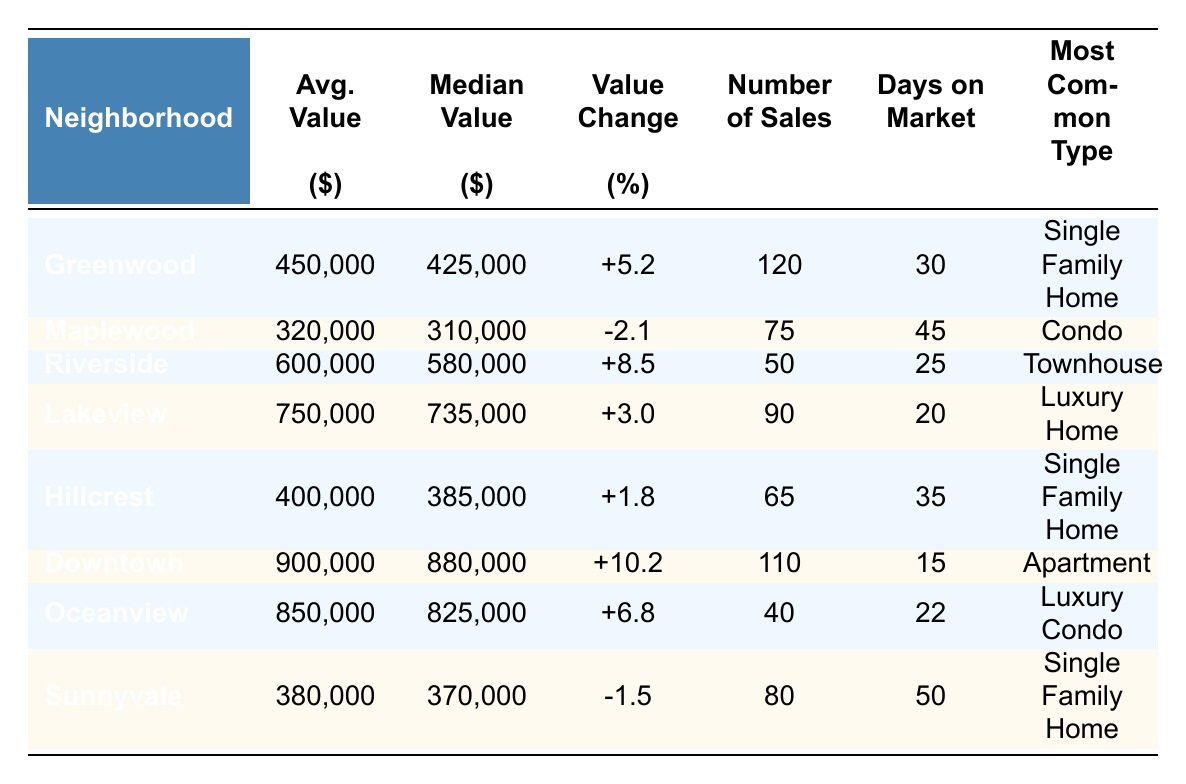What is the average property value in Riverside? The average property value for Riverside is listed directly in the table under the "Avg. Value" column, which is 600,000.
Answer: 600,000 Which neighborhood has the highest number of sales? By comparing the "Number of Sales" column, Greenwood has 120 sales, which is higher than all other neighborhoods listed.
Answer: Greenwood What is the property value change percentage for Maplewood? The property value change for Maplewood is explicitly shown in the "Value Change" column, which indicates a decrease of -2.1%.
Answer: -2.1 How many days on market did homes in Downtown have? The number of days on market for Downtown is given in the "Days on Market" column, which shows 15 days.
Answer: 15 What is the difference between average property values of Oakview and Hillcrest? Hillcrest's average value is 400,000; since there is no value for Oakview, it cannot be calculated. This question shows the limitation of the data provided because Oakview is not on the list.
Answer: N/A Is the most common property type in Lakeview a single-family home? According to the "Most Common Type" column, Lakeview's most common property type is a luxury home, not a single-family home. Therefore, the statement is false.
Answer: No How does the average property value in Downtown compare to that of Greenwood? The average property value in Downtown is 900,000, while Greenwood's average is 450,000. The difference in average property value is 900,000 - 450,000 = 450,000.
Answer: 450,000 Which neighborhood has the least days on market? The "Days on Market" column shows that Downtown has the least days, which is 15, compared to other neighborhoods.
Answer: Downtown How many neighborhoods experienced an increase in property values? By reviewing the "Value Change" column, there are 5 neighborhoods (Greenwood, Riverside, Lakeview, Downtown, and Oceanview) that show a positive change percentage.
Answer: 5 What is the median property value in Oceanview? The median property value for Oceanview is provided in the table under the "Median Value" column, which is 825,000.
Answer: 825,000 Which neighborhood has the longest average days on market? Looking at the "Days on Market" column, Sunnyvale has the longest duration at 50 days compared to the other neighborhoods.
Answer: Sunnyvale 